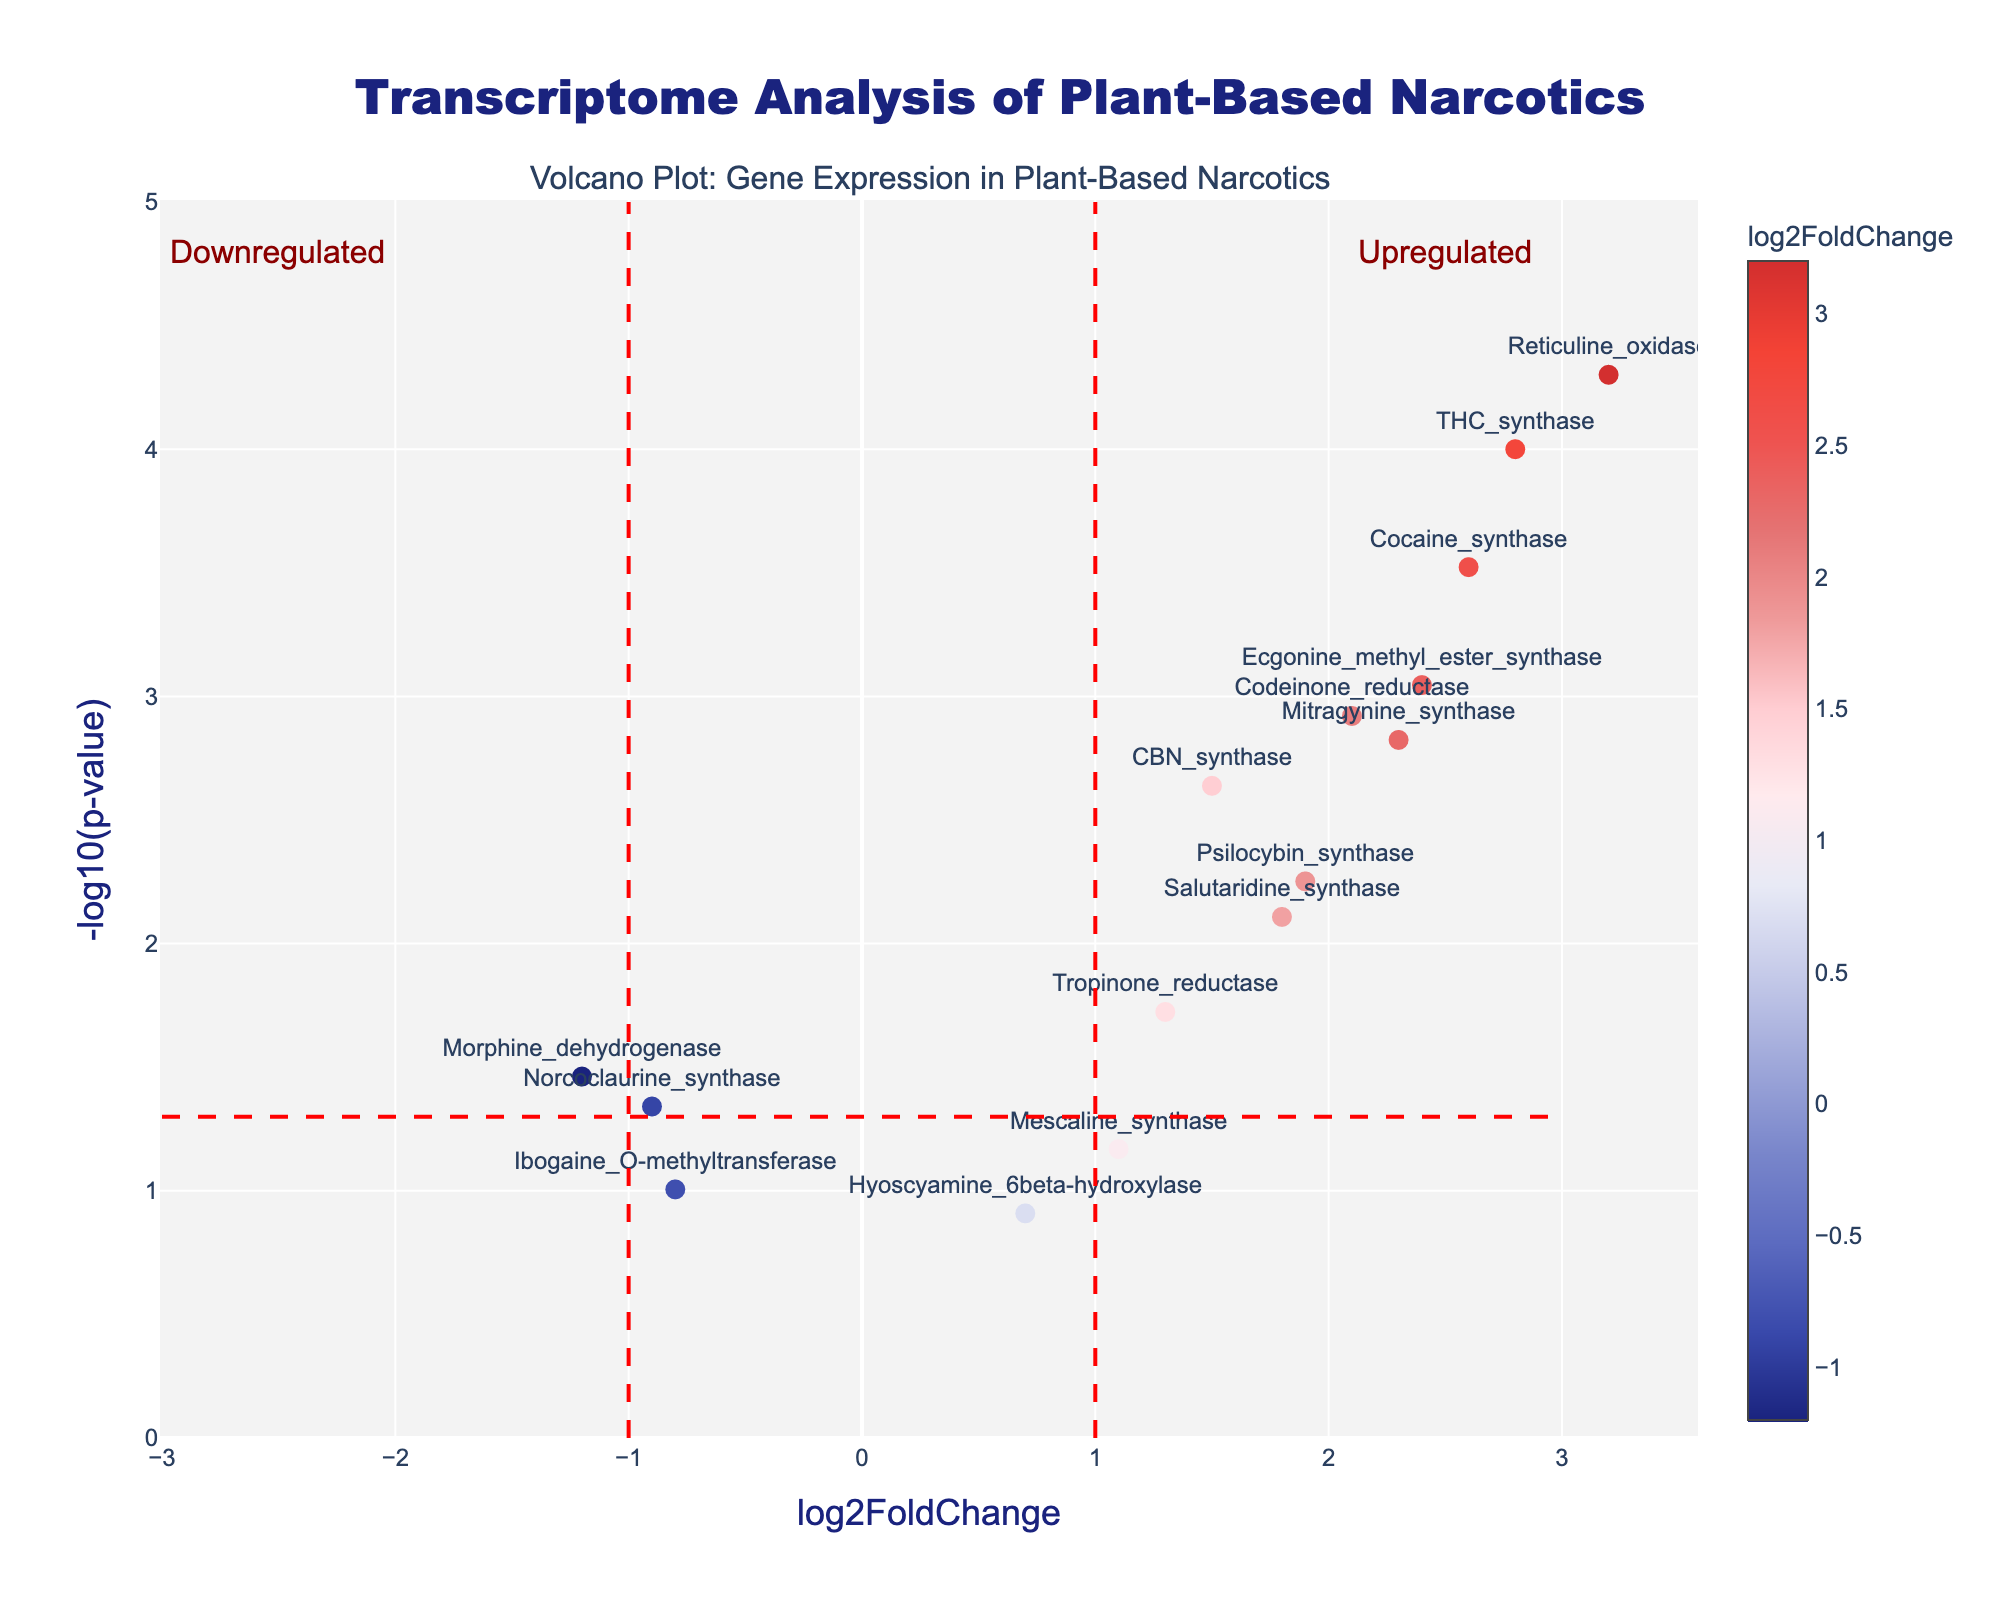What does the title of the plot indicate? The title of the plot is "Transcriptome Analysis of Plant-Based Narcotics," which suggests that the data represents the expression levels of different genes involved in the production of plant-based narcotics.
Answer: Transcriptome Analysis of Plant-Based Narcotics What are the axes labeled on the volcano plot? The x-axis is labeled "log2FoldChange" and the y-axis is labeled "-log10(p-value)", indicating that the x-axis represents the log2 fold change of gene expression and the y-axis represents the negative log10 transformation of the p-value.
Answer: log2FoldChange, -log10(p-value) How many points on the plot are beyond the threshold lines? There are three threshold lines: at log2FoldChange = -1, log2FoldChange = 1, and -log10(p-value) = 1.3. We count the points outside these boundaries to get the points beyond threshold.
Answer: 10 Which gene shows the highest log2FoldChange? The gene with the highest log2FoldChange value is "Reticuline oxidase" at 3.2. This is found by identifying the highest value on the x-axis.
Answer: Reticuline oxidase How many genes have a p-value less than 0.001? To find this, look for points with a -log10(p-value) higher than 3, since -log10(0.001) = 3. There are four such points.
Answer: 4 What is the log2FoldChange of "Norcoclaurine synthase"? The log2FoldChange for "Norcoclaurine synthase" is -0.9, as shown next to the data point labeled with this gene.
Answer: -0.9 Which gene has the lowest p-value? The lowest p-value corresponds to the highest value of -log10(p-value). "Reticuline oxidase" has the highest -log10(p-value), indicating it has the lowest p-value.
Answer: Reticuline oxidase Are there any downregulated genes with a p-value less than 0.05? Downregulated genes are those with negative log2FoldChange. By identifying which of these have a -log10(p-value) greater than -log10(0.05) ≈ 1.3, we see two points fit this criterion: "Norcoclaurine synthase" and "Morphine dehydrogenase".
Answer: Yes, two genes Which two genes are closest to the threshold line at log2FoldChange = 1? The two genes closest to the threshold line at log2FoldChange = 1 are "Psilocybin synthase" and "Mitragynine synthase", identified by their proximity to x = 1 on the plot.
Answer: Psilocybin synthase, Mitragynine synthase Are any genes labeled in regions marked as "Upregulated" or "Downregulated"? By examining the annotations, genes labeled "Upregulated" are those with log2FoldChange > 1 and -log10(p-value) > 1.3, and those labeled "Downregulated" are those with log2FoldChange < -1. "Reticuline oxidase" is upregulated, and no genes are directly labeled in the "Downregulated" region.
Answer: Yes, in "Upregulated" region 